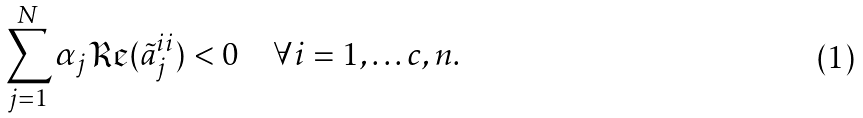<formula> <loc_0><loc_0><loc_500><loc_500>\sum _ { j = 1 } ^ { N } \alpha _ { j } \mathfrak { R e } ( \tilde { a } _ { j } ^ { i i } ) < 0 \quad \forall i = 1 , \dots c , n .</formula> 